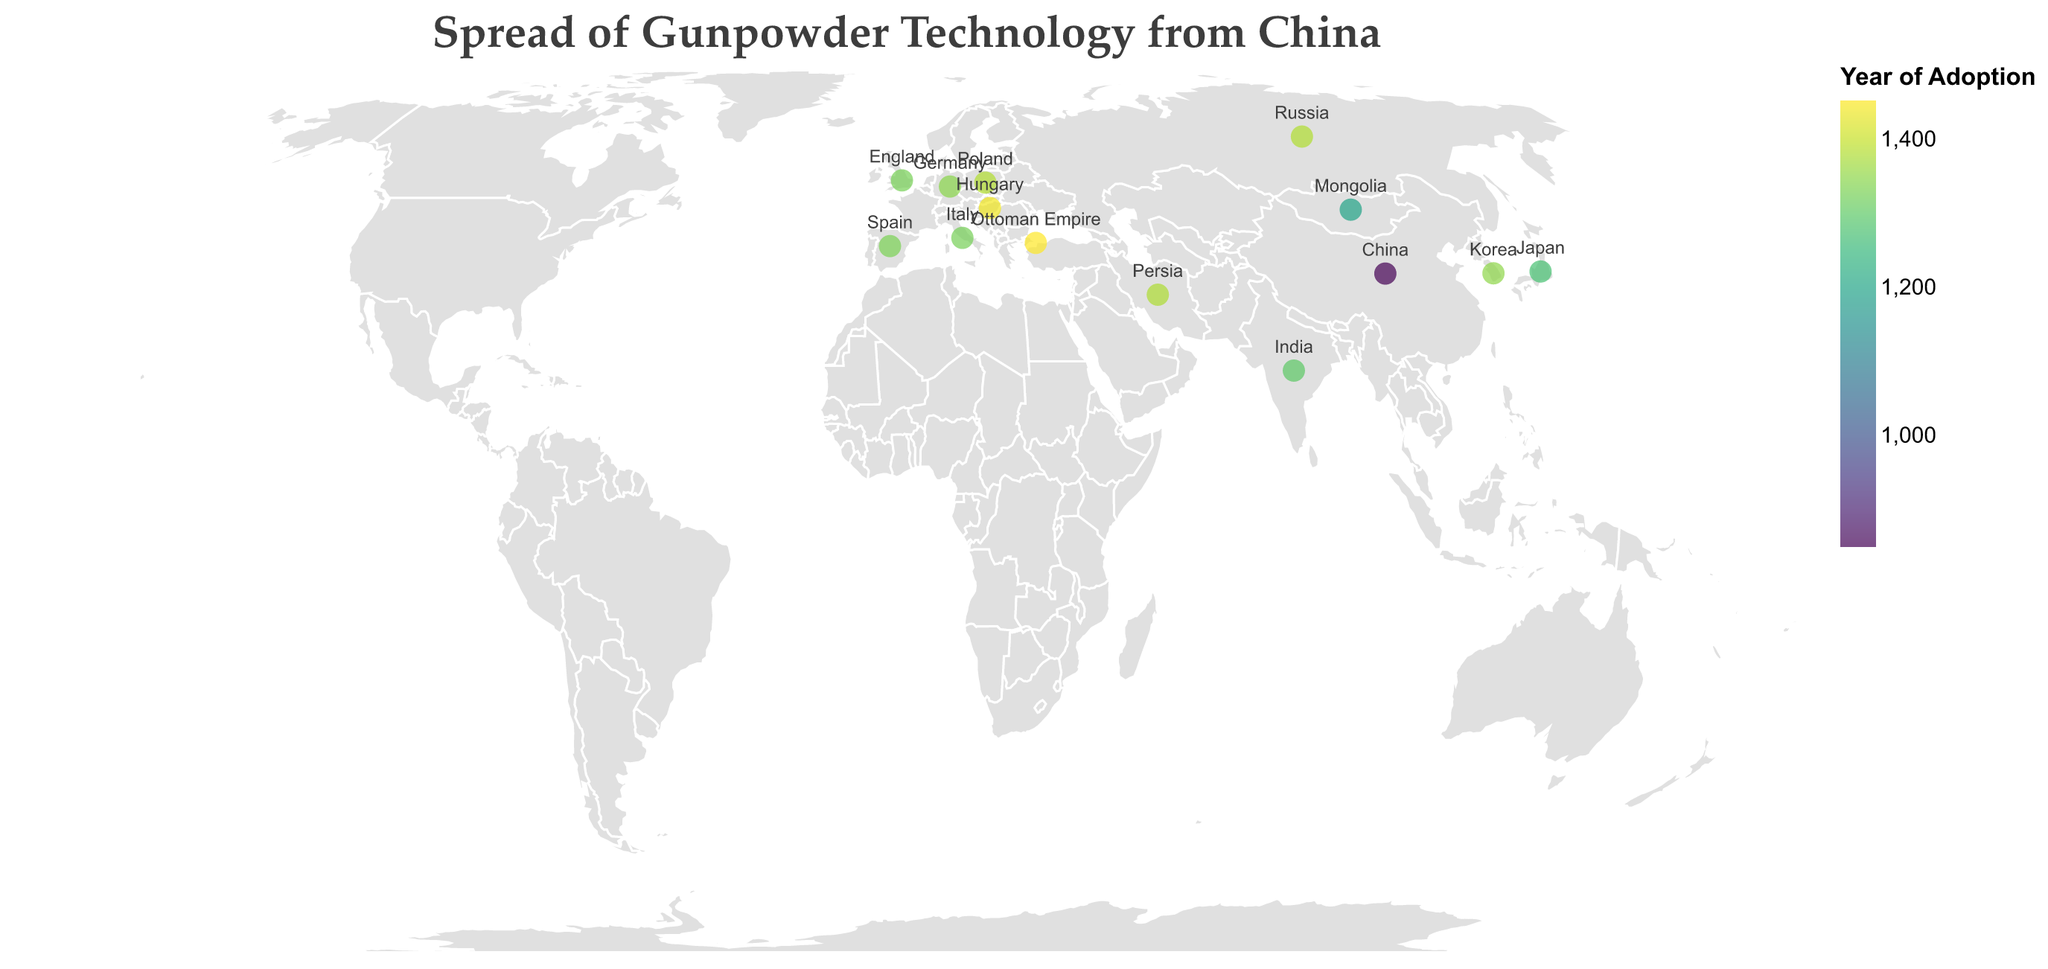What is the title of the figure? The title of the figure is displayed at the top and reads "Spread of Gunpowder Technology from China".
Answer: Spread of Gunpowder Technology from China Which country adopted gunpowder technology first according to the figure? By looking at the year values on the map, China, labeled with the year 850, adopted gunpowder technology first.
Answer: China What color represents the earliest adoption of gunpowder technology? The earliest adoption is China in the year 850, which is indicated by the color at one end of the color legend. This color is typically the lightest shade in the "viridis" color scheme used.
Answer: Light yellow What technology was adopted by the Ottoman Empire, and in what year? According to the tooltip information, the Ottoman Empire adopted "Bombard" technology in the year 1453.
Answer: Bombard, 1453 Which country adopted the technology of hand cannons, and what are their respective years of adoption? By analyzing the tooltip data, Japan adopted hand cannons in 1274, Russia in 1382, and Hungary in 1440.
Answer: Japan: 1274, Russia: 1382, Hungary: 1440 Which country adopted the cannon technology before 1400? Referring to the tooltips, Italy (1326), England (1327), Spain (1331), Persia (1380) all adopted cannon technology before 1400.
Answer: Italy, England, Spain, Persia How many different technologies are represented on this map? By counting the different technology names in the tooltip information, we have Gunpowder, Fire Lance, Hand Cannon, Hwacha, Rockets, Cannon, Bombard, and Handgonne, which makes a total of 8 different technologies.
Answer: 8 Between which two countries did the spread of gunpowder technology take the longest time, and how many years did it take? The spread of gunpowder technology from China (850) to the Ottoman Empire (1453) took 603 years, which is the longest time span between any two countries listed.
Answer: China and the Ottoman Empire, 603 years Which technology appears to have spread to the most number of countries based on the map? By counting the occurrences of each technology from the tooltips, "Cannon" technology appears in Italy, Persia, England, and Spain, indicating it has spread to 4 countries.
Answer: Cannon 